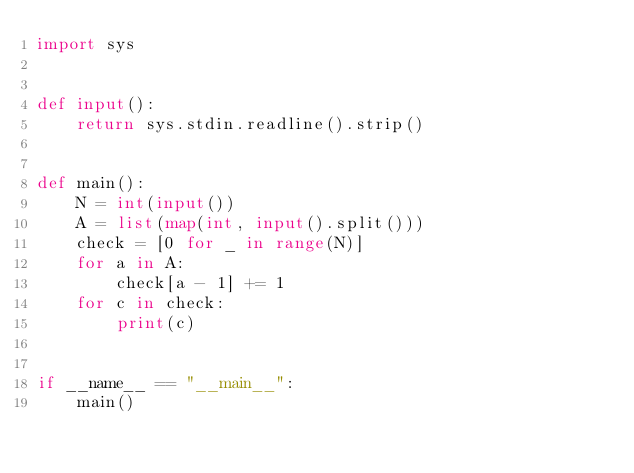<code> <loc_0><loc_0><loc_500><loc_500><_Python_>import sys


def input():
    return sys.stdin.readline().strip()


def main():
    N = int(input())
    A = list(map(int, input().split()))
    check = [0 for _ in range(N)]
    for a in A:
        check[a - 1] += 1
    for c in check:
        print(c)


if __name__ == "__main__":
    main()
</code> 